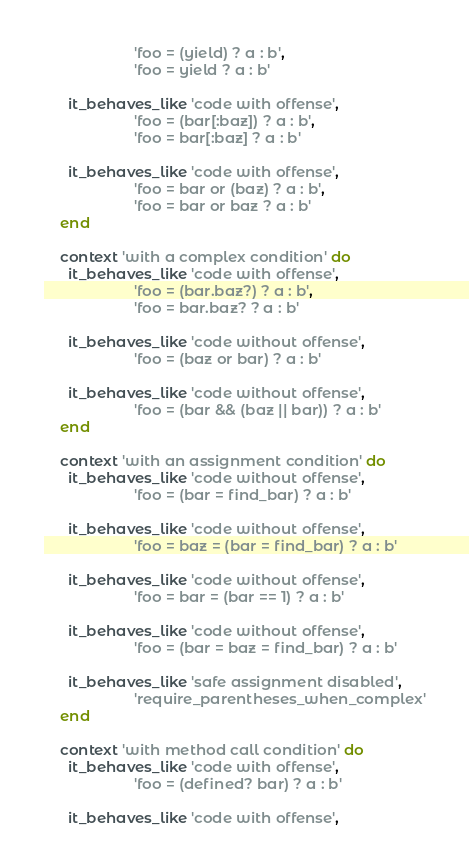Convert code to text. <code><loc_0><loc_0><loc_500><loc_500><_Ruby_>                      'foo = (yield) ? a : b',
                      'foo = yield ? a : b'

      it_behaves_like 'code with offense',
                      'foo = (bar[:baz]) ? a : b',
                      'foo = bar[:baz] ? a : b'

      it_behaves_like 'code with offense',
                      'foo = bar or (baz) ? a : b',
                      'foo = bar or baz ? a : b'
    end

    context 'with a complex condition' do
      it_behaves_like 'code with offense',
                      'foo = (bar.baz?) ? a : b',
                      'foo = bar.baz? ? a : b'

      it_behaves_like 'code without offense',
                      'foo = (baz or bar) ? a : b'

      it_behaves_like 'code without offense',
                      'foo = (bar && (baz || bar)) ? a : b'
    end

    context 'with an assignment condition' do
      it_behaves_like 'code without offense',
                      'foo = (bar = find_bar) ? a : b'

      it_behaves_like 'code without offense',
                      'foo = baz = (bar = find_bar) ? a : b'

      it_behaves_like 'code without offense',
                      'foo = bar = (bar == 1) ? a : b'

      it_behaves_like 'code without offense',
                      'foo = (bar = baz = find_bar) ? a : b'

      it_behaves_like 'safe assignment disabled',
                      'require_parentheses_when_complex'
    end

    context 'with method call condition' do
      it_behaves_like 'code with offense',
                      'foo = (defined? bar) ? a : b'

      it_behaves_like 'code with offense',</code> 